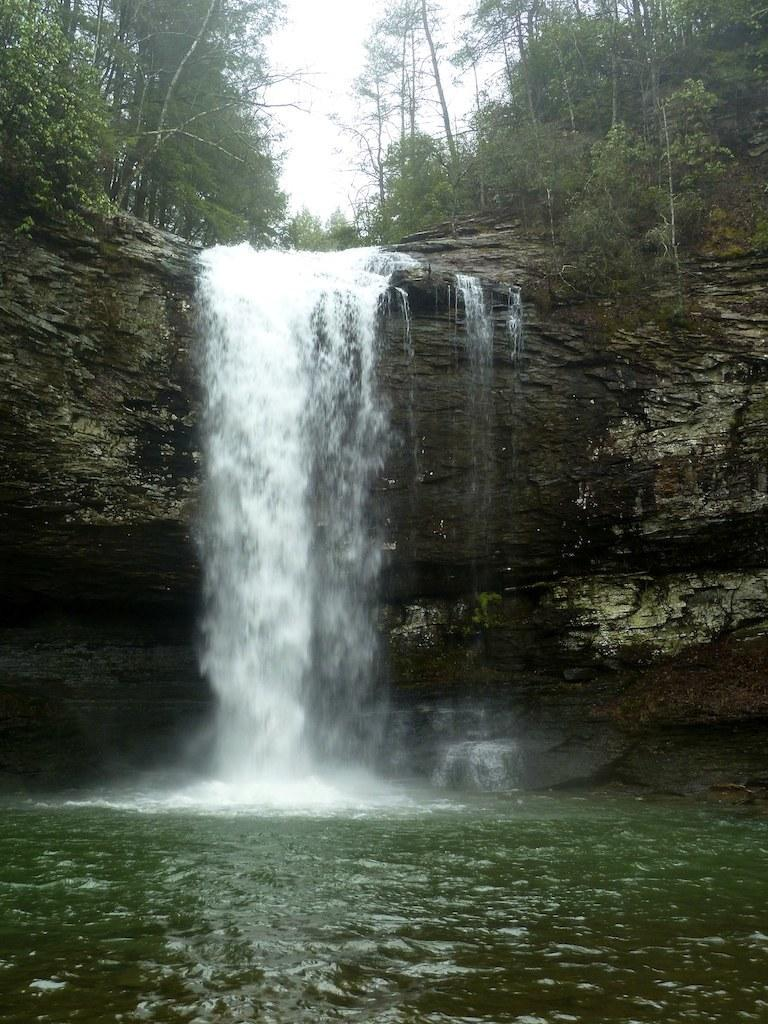What natural feature is the main subject of the image? There is a waterfall in the image. What can be seen behind the waterfall? There are trees behind the waterfall. What part of the natural environment is visible in the image? The sky is visible in the image. Where is the scarecrow located in the image? There is no scarecrow present in the image. What is the distance between the waterfall and the trees in the image? The facts provided do not give information about the distance between the waterfall and the trees, so it cannot be determined from the image. 